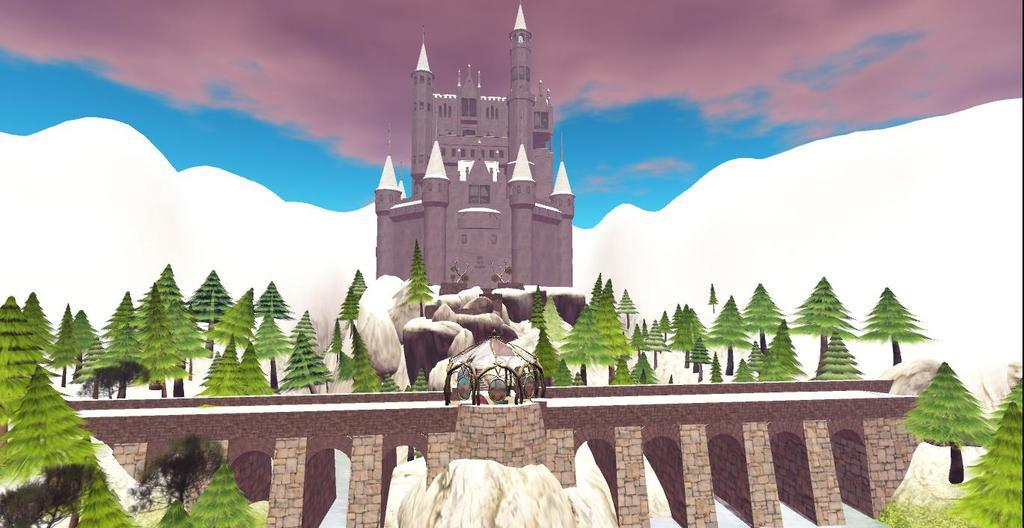What type of structure is in the image? There is a castle in the image. What other natural elements can be seen in the image? There are many trees in the image. What is visible in the background of the image? The sky is visible in the background of the image. What body of water is present in the image? There is a reservoir at the bottom of the image. What type of arch can be seen supporting the castle in the image? There is no arch visible in the image; it only shows a castle, trees, the sky, and a reservoir. 